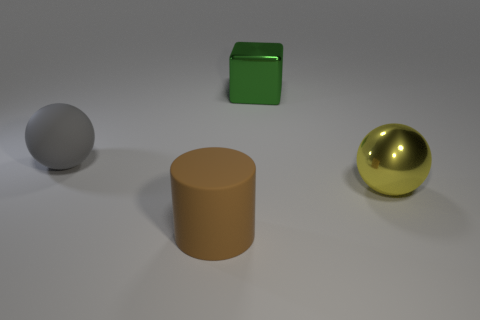Are there an equal number of things that are to the right of the large green thing and metal things that are behind the big yellow metallic object?
Offer a very short reply. Yes. Are there any big things that have the same material as the large brown cylinder?
Your answer should be very brief. Yes. Is the material of the big green cube on the right side of the large rubber ball the same as the large gray sphere?
Your answer should be very brief. No. What is the size of the object that is in front of the gray matte object and on the left side of the yellow metal sphere?
Provide a short and direct response. Large. The big metallic cube is what color?
Your answer should be very brief. Green. What number of big blue rubber objects are there?
Ensure brevity in your answer.  0. What number of shiny things have the same color as the big rubber ball?
Provide a succinct answer. 0. Do the metallic object behind the large gray matte thing and the metal thing in front of the big metal block have the same shape?
Offer a very short reply. No. There is a large ball to the left of the large shiny object that is right of the large metallic thing to the left of the shiny sphere; what is its color?
Give a very brief answer. Gray. There is a big object in front of the yellow metallic ball; what is its color?
Your answer should be compact. Brown. 